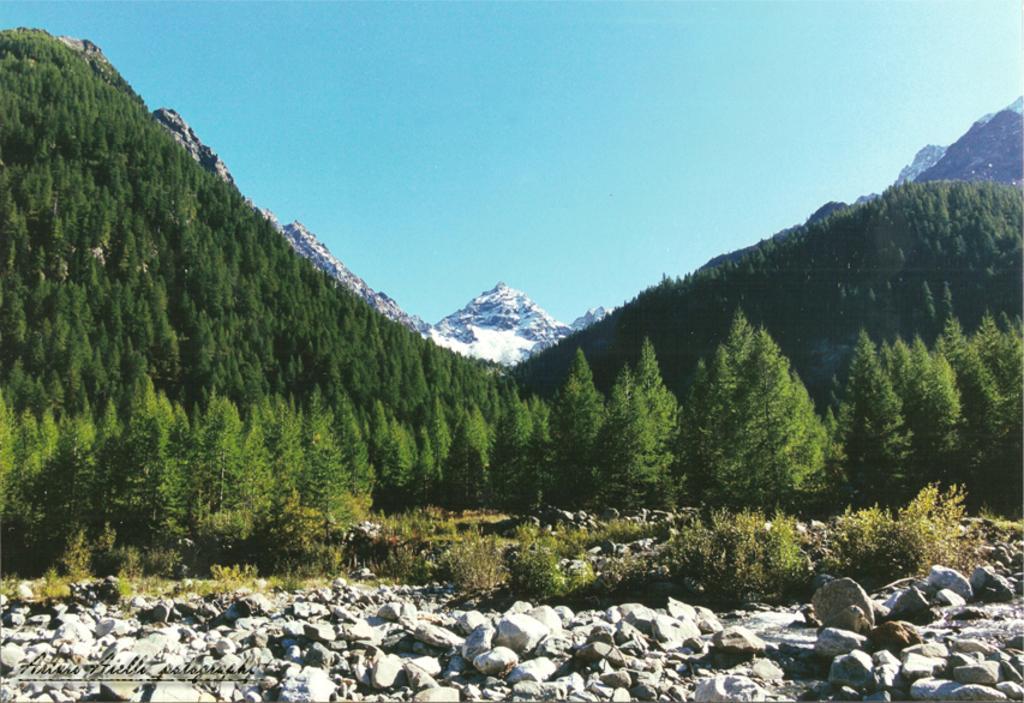Can you describe this image briefly? In this picture I can see there are rocks, and there is water flowing in between the rocks and in the backdrop there are plants, trees and mountains which are covered with trees and snow and in the backdrop I can see the sky is clear. 